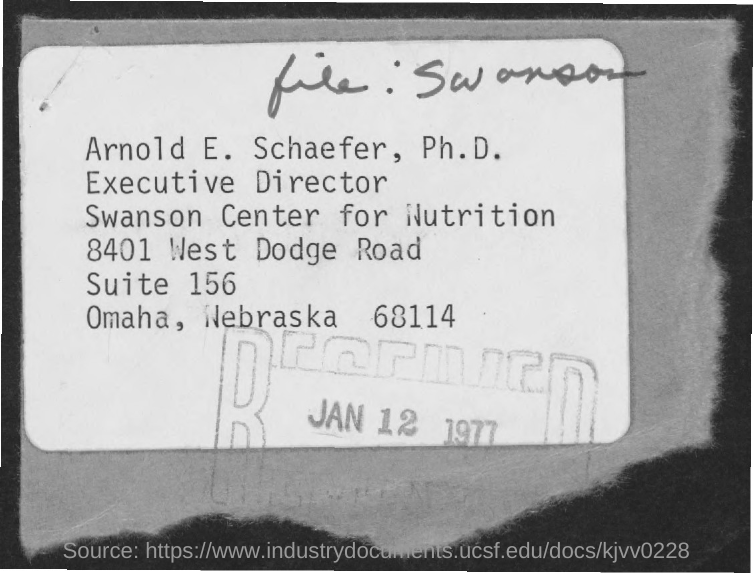What is the number of West Dodge Road?
Your answer should be very brief. 8401. What is the number of suite?
Provide a succinct answer. 156. What is the pincode of Omaha, Nebraska?
Your answer should be compact. 68114. What is the date on the stamp?
Give a very brief answer. Jan 12 1977. 